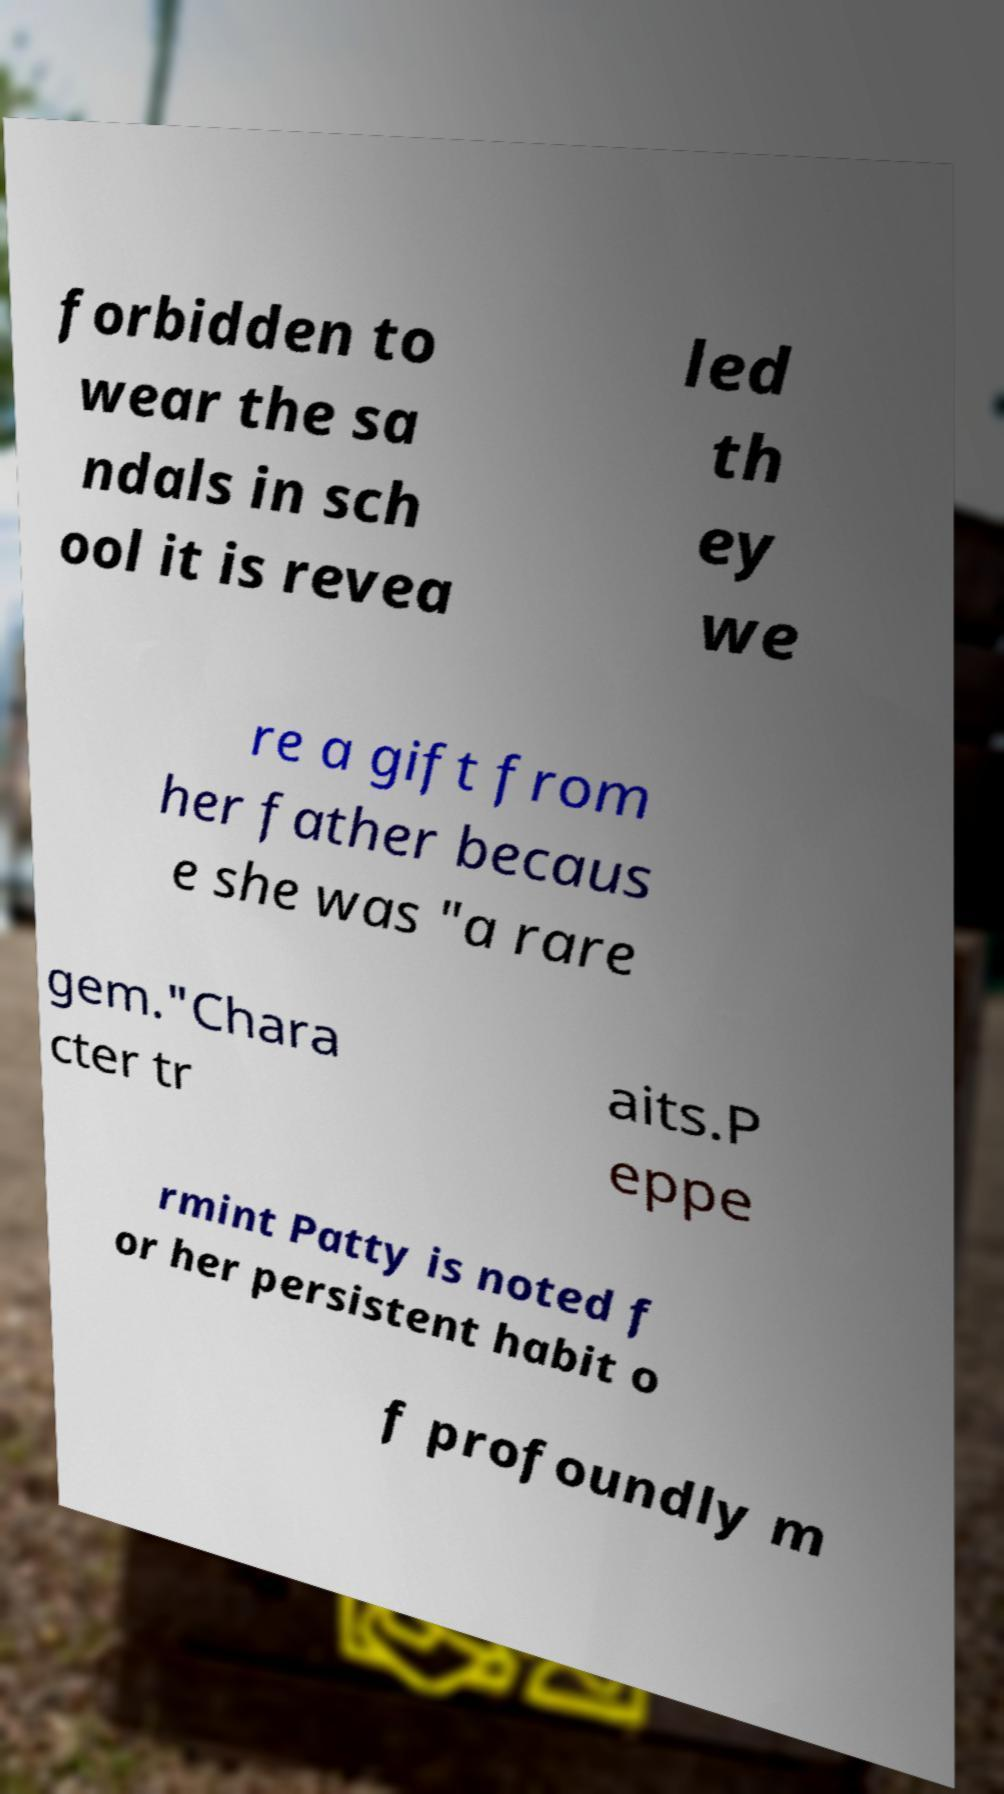Can you read and provide the text displayed in the image?This photo seems to have some interesting text. Can you extract and type it out for me? forbidden to wear the sa ndals in sch ool it is revea led th ey we re a gift from her father becaus e she was "a rare gem."Chara cter tr aits.P eppe rmint Patty is noted f or her persistent habit o f profoundly m 